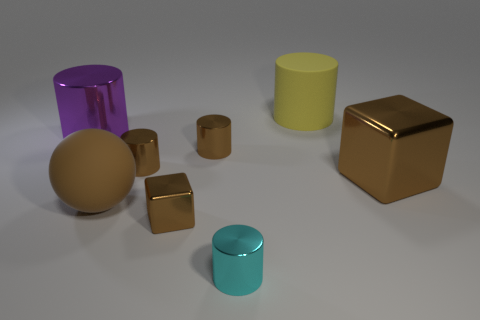Does the large matte sphere have the same color as the tiny cube?
Provide a short and direct response. Yes. What number of large cylinders are right of the large cylinder left of the tiny metallic cylinder that is in front of the big brown metallic thing?
Your response must be concise. 1. The yellow thing that is the same material as the large brown sphere is what shape?
Offer a terse response. Cylinder. What is the material of the cylinder that is in front of the large brown thing on the right side of the metallic block to the left of the yellow matte cylinder?
Ensure brevity in your answer.  Metal. How many things are metallic blocks that are on the left side of the yellow matte cylinder or tiny brown metal blocks?
Give a very brief answer. 1. How many other things are the same shape as the small cyan thing?
Give a very brief answer. 4. Are there more yellow cylinders that are right of the large brown metal block than large yellow objects?
Give a very brief answer. No. The cyan thing that is the same shape as the large purple metal thing is what size?
Ensure brevity in your answer.  Small. The big yellow thing is what shape?
Offer a terse response. Cylinder. The yellow matte object that is the same size as the purple metallic thing is what shape?
Make the answer very short. Cylinder. 